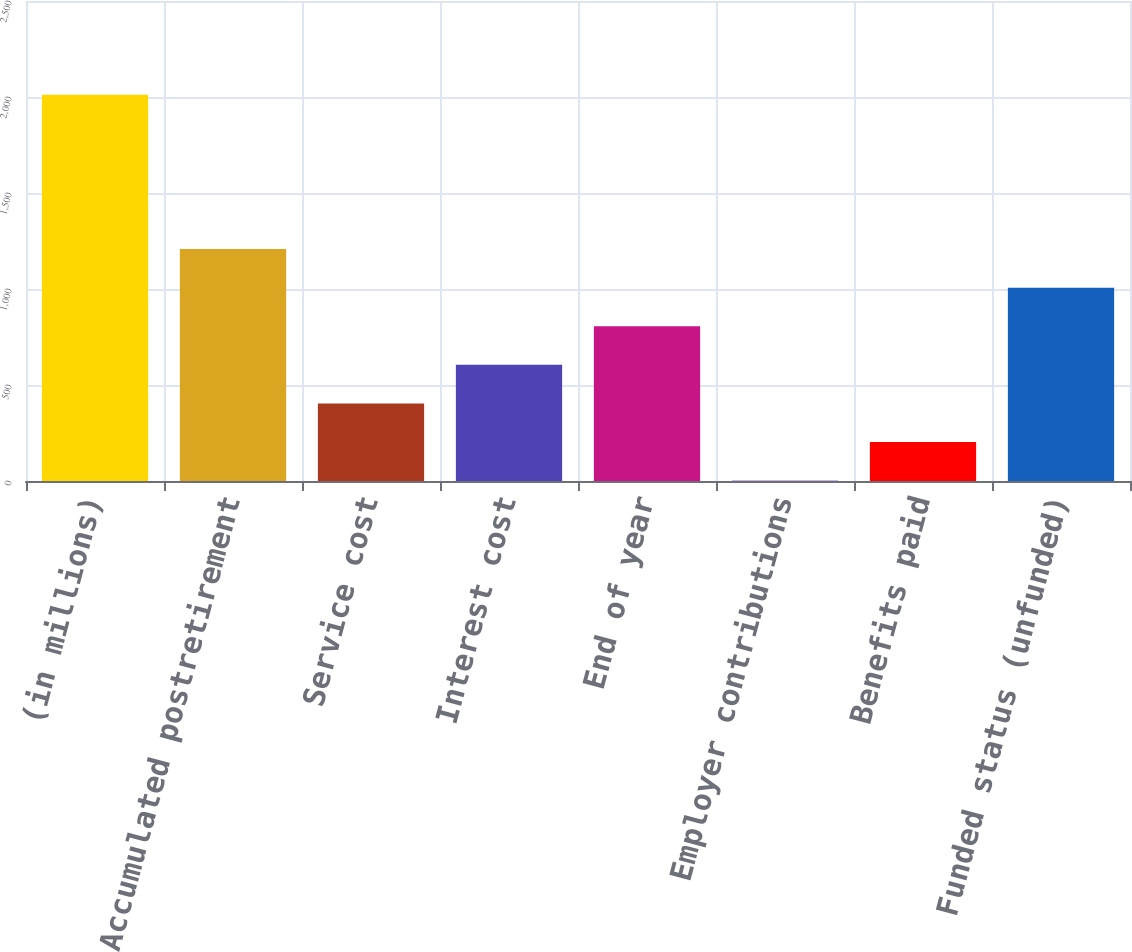<chart> <loc_0><loc_0><loc_500><loc_500><bar_chart><fcel>(in millions)<fcel>Accumulated postretirement<fcel>Service cost<fcel>Interest cost<fcel>End of year<fcel>Employer contributions<fcel>Benefits paid<fcel>Funded status (unfunded)<nl><fcel>2012<fcel>1208<fcel>404<fcel>605<fcel>806<fcel>2<fcel>203<fcel>1007<nl></chart> 